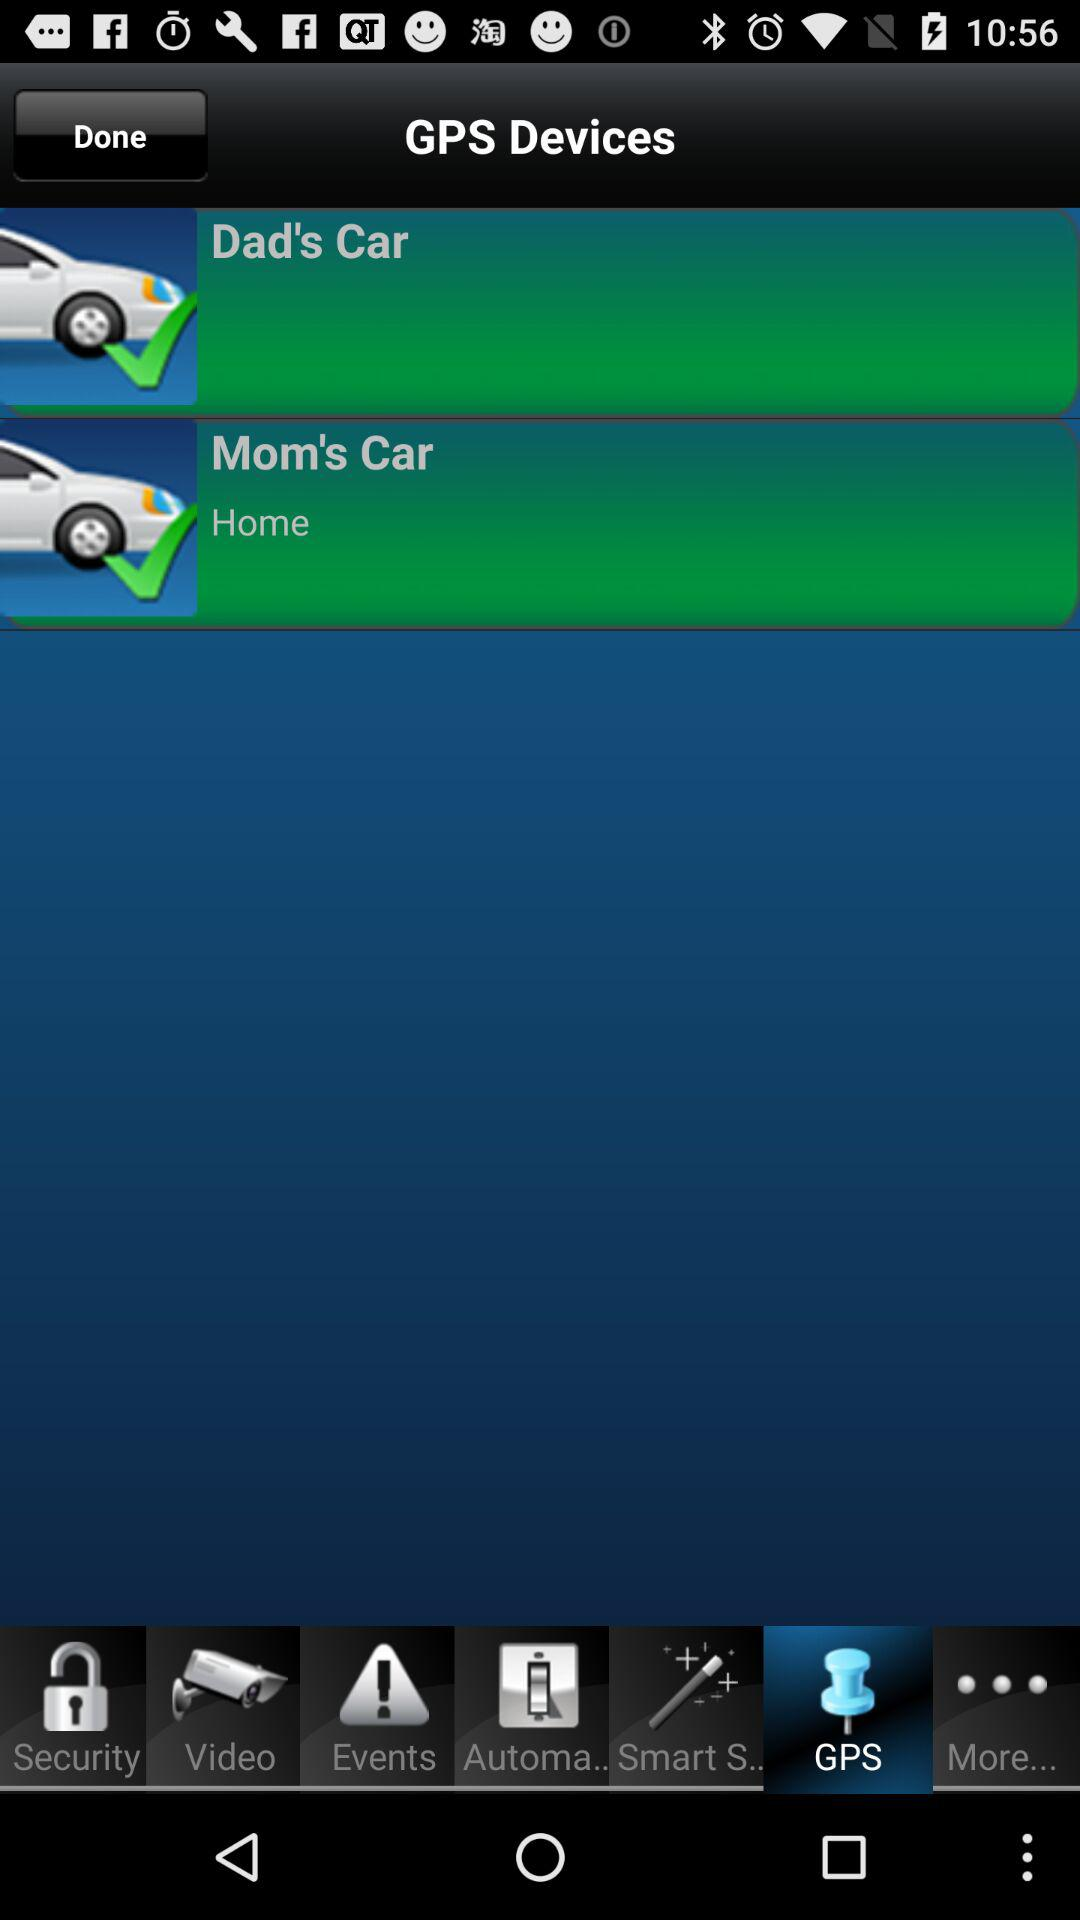What option is in the "GPS devices"? The options are "Dad's Car" and "Mom's Car". 